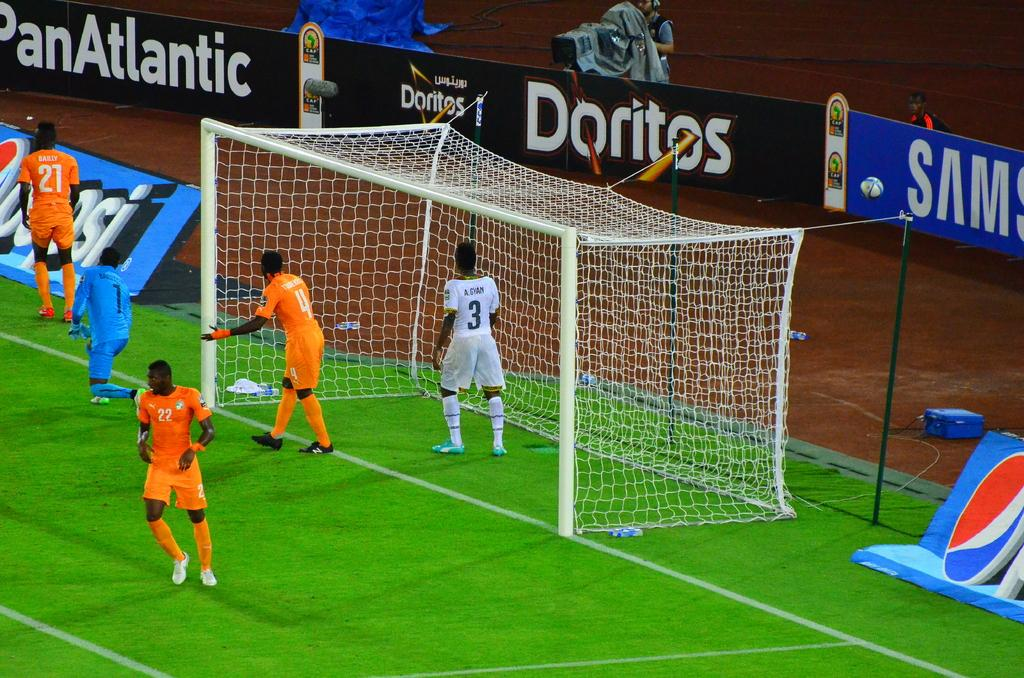<image>
Give a short and clear explanation of the subsequent image. The home team at this soccer game is sponsored by PanAtlantic, Doritos, and Samsung. 